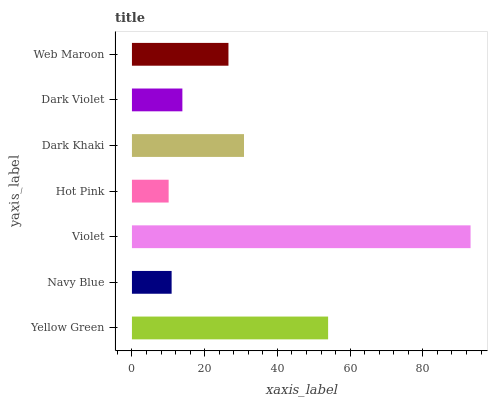Is Hot Pink the minimum?
Answer yes or no. Yes. Is Violet the maximum?
Answer yes or no. Yes. Is Navy Blue the minimum?
Answer yes or no. No. Is Navy Blue the maximum?
Answer yes or no. No. Is Yellow Green greater than Navy Blue?
Answer yes or no. Yes. Is Navy Blue less than Yellow Green?
Answer yes or no. Yes. Is Navy Blue greater than Yellow Green?
Answer yes or no. No. Is Yellow Green less than Navy Blue?
Answer yes or no. No. Is Web Maroon the high median?
Answer yes or no. Yes. Is Web Maroon the low median?
Answer yes or no. Yes. Is Hot Pink the high median?
Answer yes or no. No. Is Violet the low median?
Answer yes or no. No. 